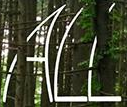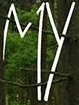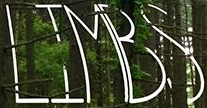What words can you see in these images in sequence, separated by a semicolon? ALL; MY; LIMBS 